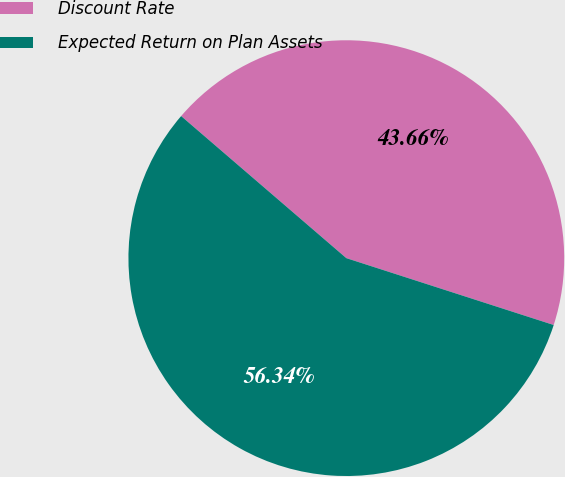<chart> <loc_0><loc_0><loc_500><loc_500><pie_chart><fcel>Discount Rate<fcel>Expected Return on Plan Assets<nl><fcel>43.66%<fcel>56.34%<nl></chart> 